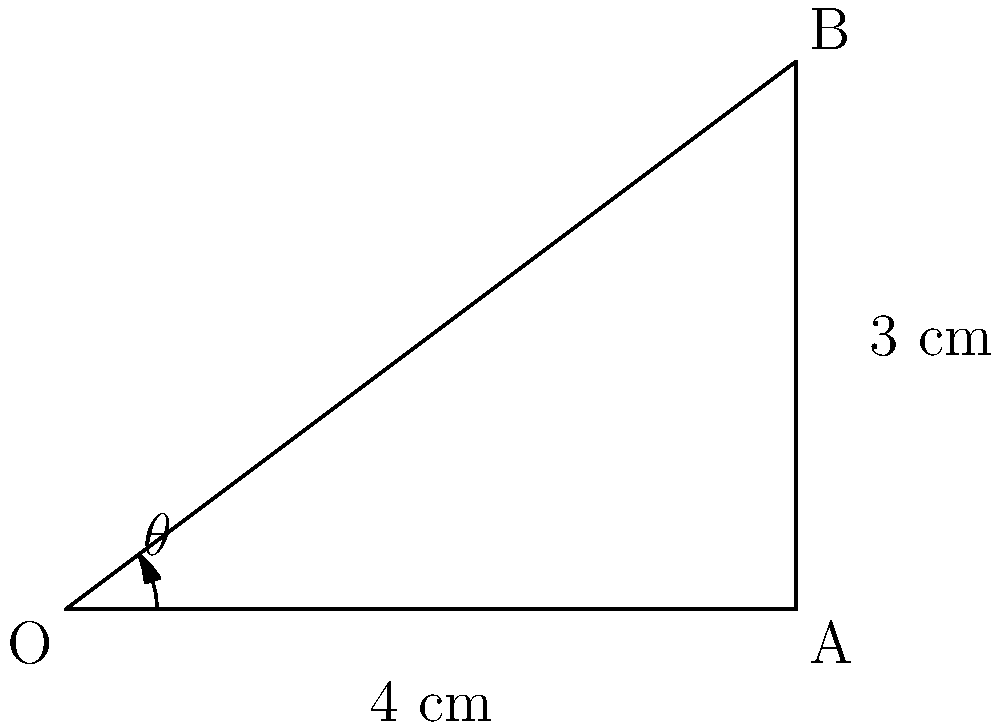In a biomimetic composite material designed to mimic natural bone structure, the angle of fiber alignment is crucial for optimal mechanical properties. Given the diagram representing a cross-section of the material, where OA is 4 cm and AB is 3 cm, calculate the angle $\theta$ of fiber alignment with respect to the horizontal axis. Express your answer in degrees, rounded to the nearest whole number. To find the angle $\theta$ of fiber alignment, we can use the trigonometric relationship in the right-angled triangle OAB:

1) We know the adjacent side (OA) is 4 cm and the opposite side (AB) is 3 cm.

2) The tangent of an angle in a right-angled triangle is defined as the ratio of the opposite side to the adjacent side:

   $\tan(\theta) = \frac{\text{opposite}}{\text{adjacent}} = \frac{AB}{OA} = \frac{3}{4}$

3) To find $\theta$, we need to use the inverse tangent (arctan or $\tan^{-1}$) function:

   $\theta = \tan^{-1}(\frac{3}{4})$

4) Using a calculator or computational tool:

   $\theta \approx 36.87°$

5) Rounding to the nearest whole number:

   $\theta \approx 37°$

Therefore, the angle of fiber alignment with respect to the horizontal axis is approximately 37°.
Answer: 37° 